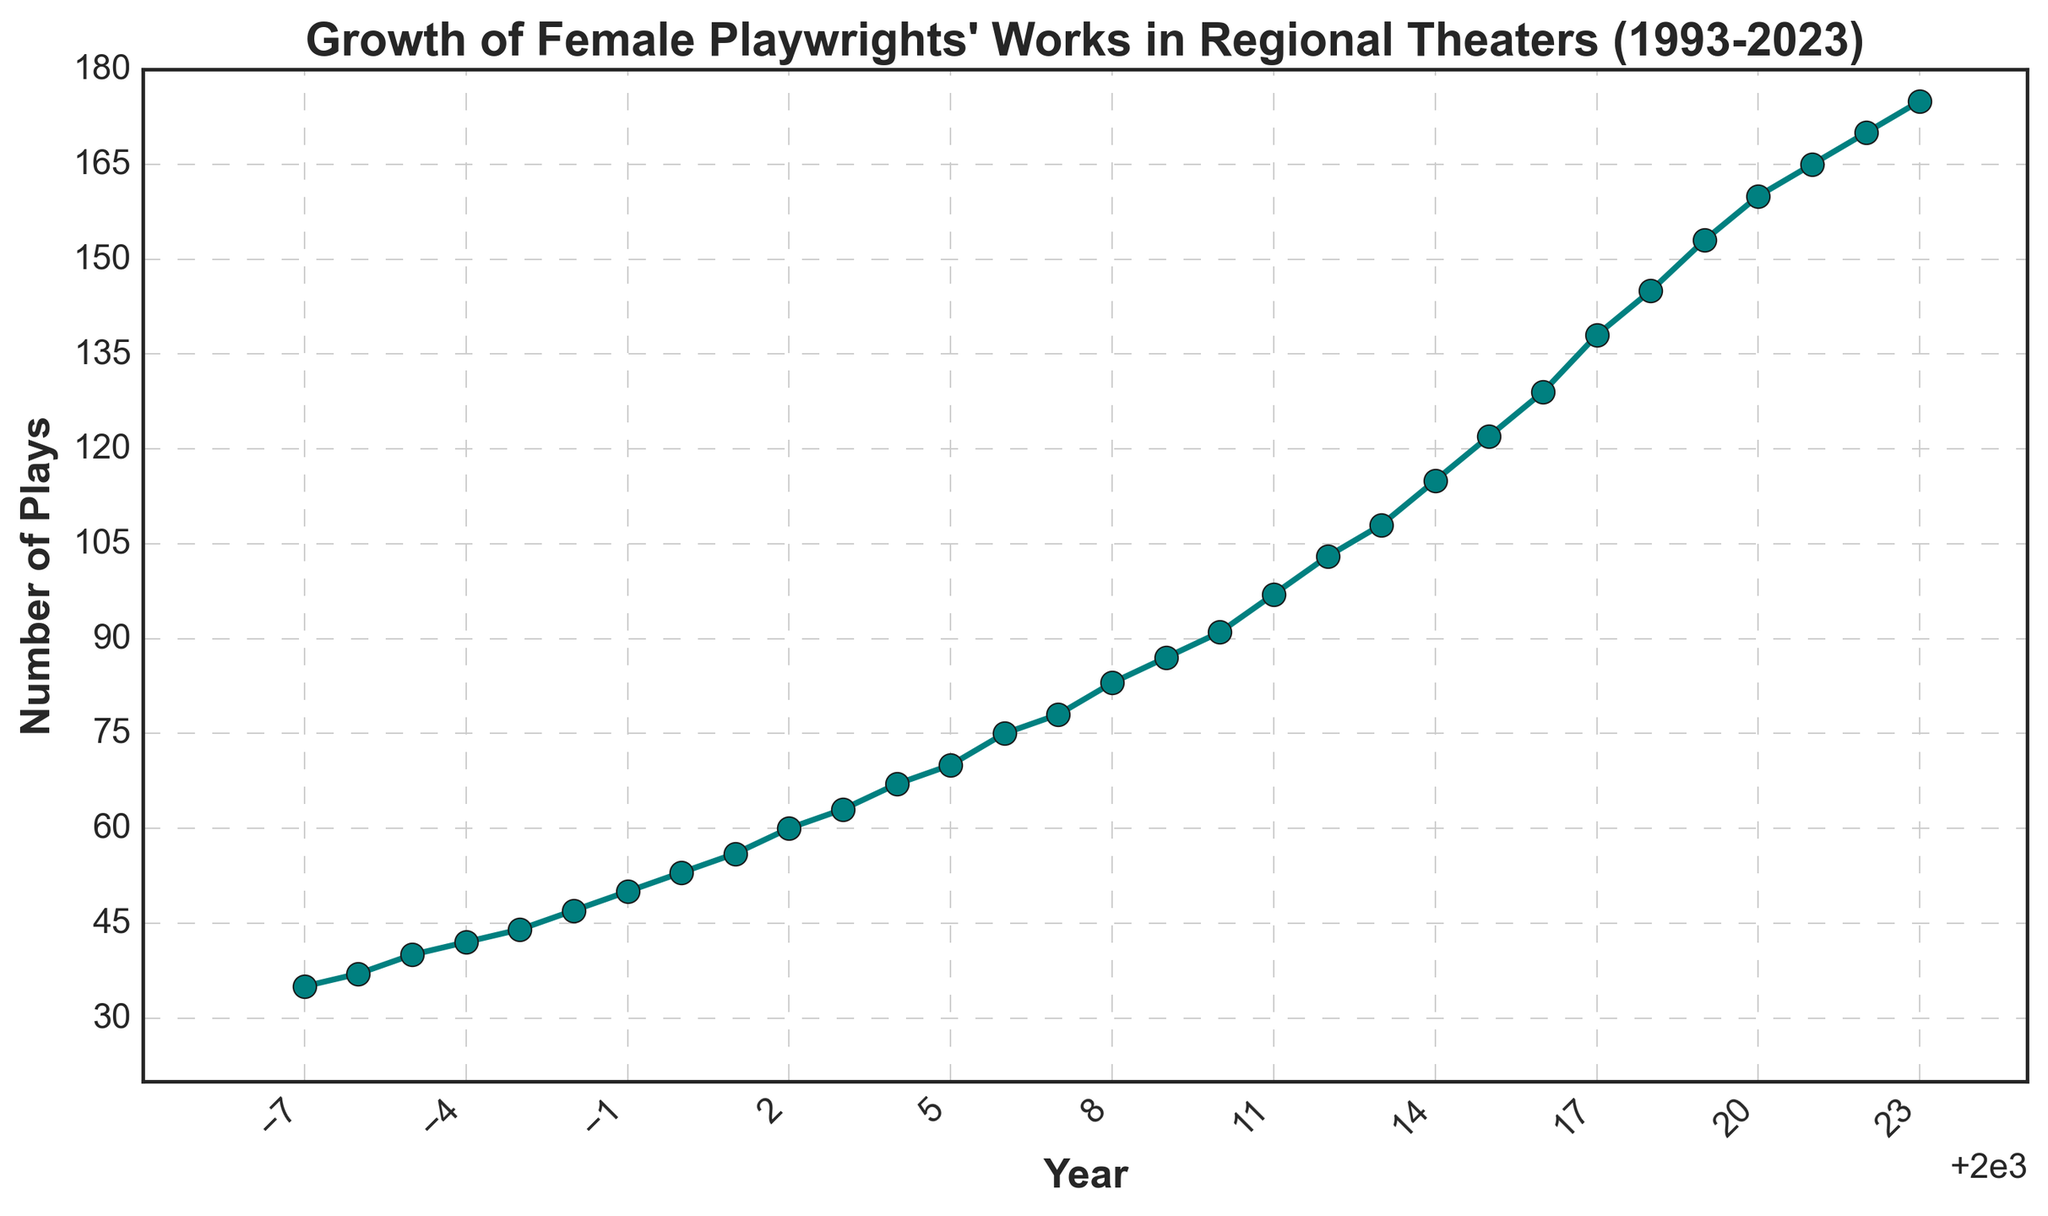What is the overall trend in the number of plays by female playwrights over the years? The line chart shows an increasing trend in the number of plays by female playwrights produced in regional theaters from 1993 to 2023. This indicates growth over the entire period.
Answer: Increasing In which year did the number of plays by female playwrights first reach 100? On the chart, the number of plays by female playwrights first surpasses 100 in 2012. This is observed when the y-value associated with the year 2012 crosses the 100 plays mark on the y-axis.
Answer: 2012 What is the difference between the number of plays in 1993 and 2023? To find this difference, subtract the number of plays in 1993 from the number of plays in 2023, which is 175 - 35 = 140.
Answer: 140 How many years did it take for the number of plays to roughly double from its 1993 value? The number of plays in 1993 is 35, and doubling this value gives 70. Observing the chart, the number of plays reaches 70 around 2005. Thus, it took approximately 12 years (2005 - 1993).
Answer: 12 years Which year experienced the steepest increase in the number of plays produced? By examining the slope between consecutive years, the steepest increase appears between 2016 and 2017. Here, the number of plays rose from 129 to 138, making an increase of 9 plays.
Answer: 2016-2017 What is the average number of plays produced per year over the entire period? Sum up all the data points and divide by the number of years (31 years). Total sum = 35 + 37 + 40 + 42 + ... + 170 + 175 = 2799. Average = 2799 / 31 ≈ 90.29.
Answer: 90.29 Compare the number of plays produced in 2000 and 2020. Which year had more, and by how much? In 2000, the number of plays produced was 53, and in 2020, it was 160. The difference is 160 - 53 = 107. Thus, 2020 had 107 more plays than 2000.
Answer: 2020 had 107 more What visual markers are used to denote the data points on the chart? The data points on the chart are marked with circles ('o') and connected by teal-colored lines.
Answer: Circles and teal-colored lines How consistent is the growth in the number of plays by female playwrights from 1993 to 2023? The growth is relatively consistent, with a steady upward trend throughout the period. There are no major dips or periods where the number of plays decreases.
Answer: Consistent Identify the first three years where the number of plays increased by more than 10 from the previous year. First, identify the years where the increase is more than 10 by observing the chart: (1) 2011 to 2012 (from 97 to 103), (2) 2012 to 2013 (from 103 to 108), (3) 2013 to 2014 (from 108 to 115).
Answer: 2011-2012, 2012-2013, 2013-2014 